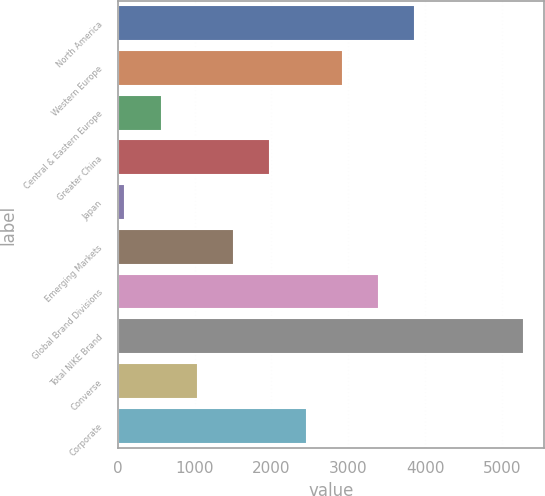Convert chart. <chart><loc_0><loc_0><loc_500><loc_500><bar_chart><fcel>North America<fcel>Western Europe<fcel>Central & Eastern Europe<fcel>Greater China<fcel>Japan<fcel>Emerging Markets<fcel>Global Brand Divisions<fcel>Total NIKE Brand<fcel>Converse<fcel>Corporate<nl><fcel>3873.6<fcel>2930.2<fcel>571.7<fcel>1986.8<fcel>100<fcel>1515.1<fcel>3401.9<fcel>5288.7<fcel>1043.4<fcel>2458.5<nl></chart> 